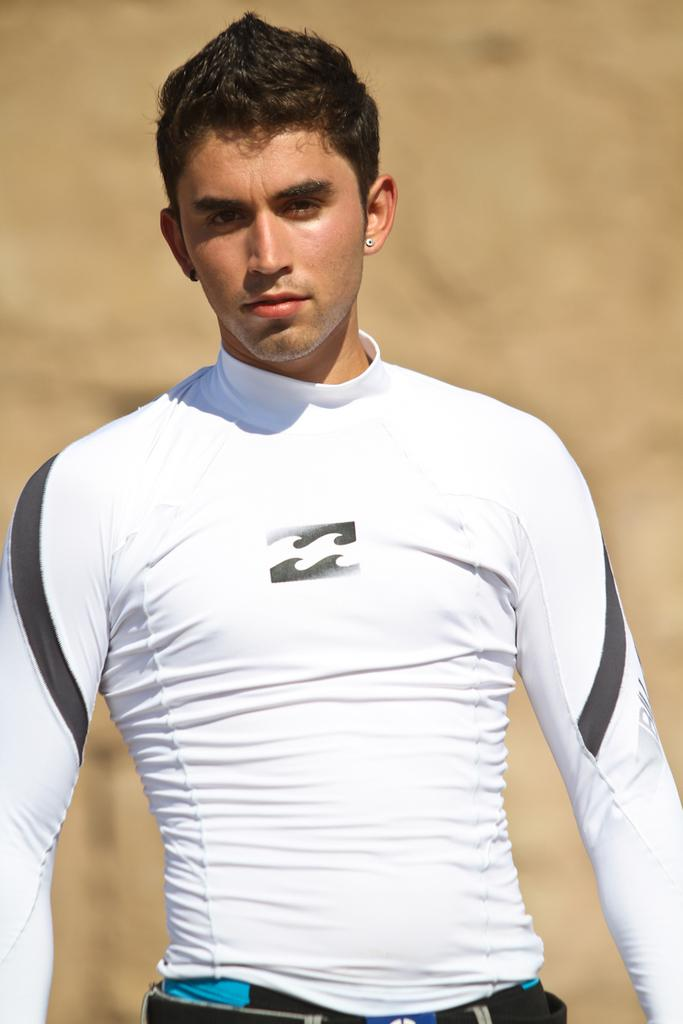What is present in the image? There is a person in the image. What is the person wearing? The person is wearing a white and black color T-shirt. What is the person's posture in the image? The person is standing. What type of wren can be seen perched on the person's shoulder in the image? There is no wren present in the image; only the person wearing a white and black color T-shirt is visible. 